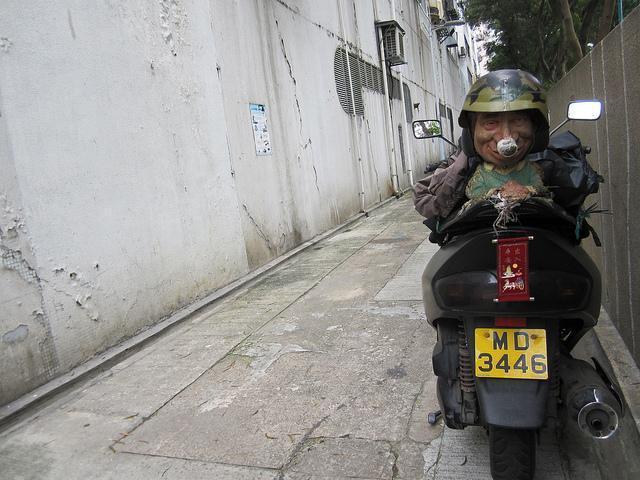How many motorcycles are visible?
Give a very brief answer. 1. 